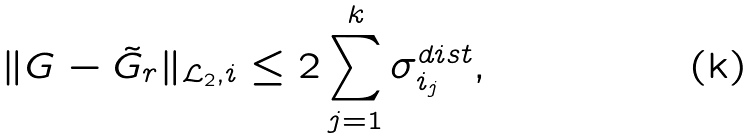<formula> <loc_0><loc_0><loc_500><loc_500>\| G - \tilde { G } _ { r } \| _ { \mathcal { L } _ { 2 } , i } \leq 2 \sum _ { j = 1 } ^ { k } \sigma ^ { d i s t } _ { i _ { j } } ,</formula> 